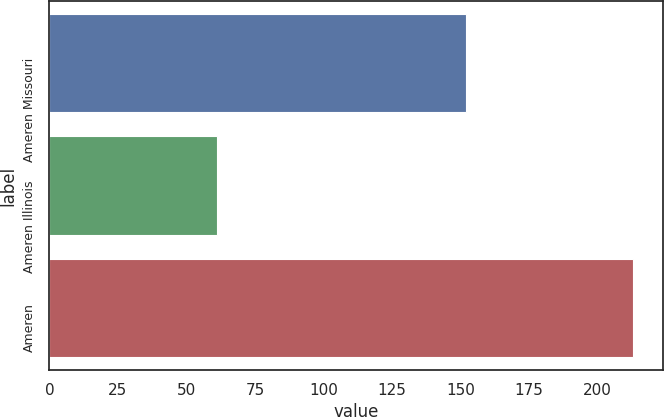<chart> <loc_0><loc_0><loc_500><loc_500><bar_chart><fcel>Ameren Missouri<fcel>Ameren Illinois<fcel>Ameren<nl><fcel>152<fcel>61<fcel>213<nl></chart> 